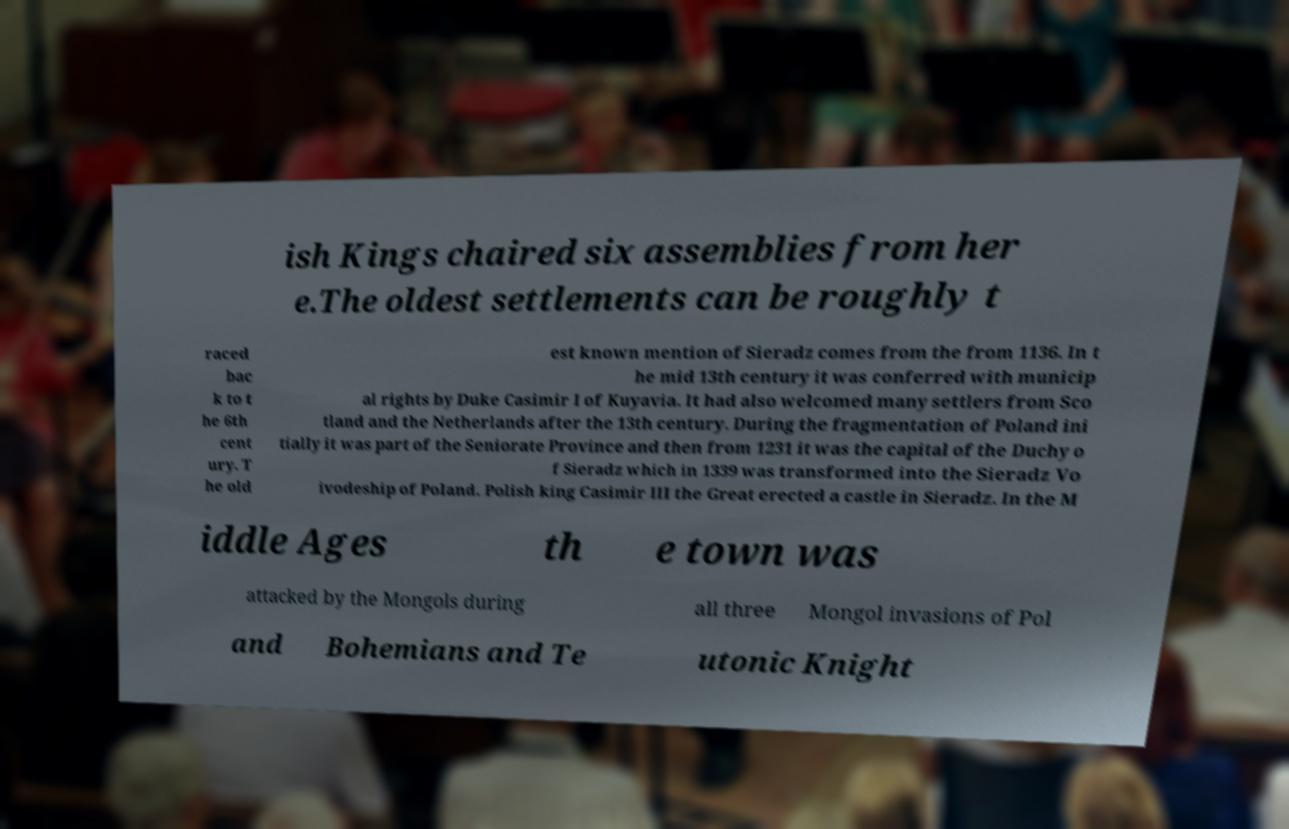Please read and relay the text visible in this image. What does it say? ish Kings chaired six assemblies from her e.The oldest settlements can be roughly t raced bac k to t he 6th cent ury. T he old est known mention of Sieradz comes from the from 1136. In t he mid 13th century it was conferred with municip al rights by Duke Casimir I of Kuyavia. It had also welcomed many settlers from Sco tland and the Netherlands after the 13th century. During the fragmentation of Poland ini tially it was part of the Seniorate Province and then from 1231 it was the capital of the Duchy o f Sieradz which in 1339 was transformed into the Sieradz Vo ivodeship of Poland. Polish king Casimir III the Great erected a castle in Sieradz. In the M iddle Ages th e town was attacked by the Mongols during all three Mongol invasions of Pol and Bohemians and Te utonic Knight 